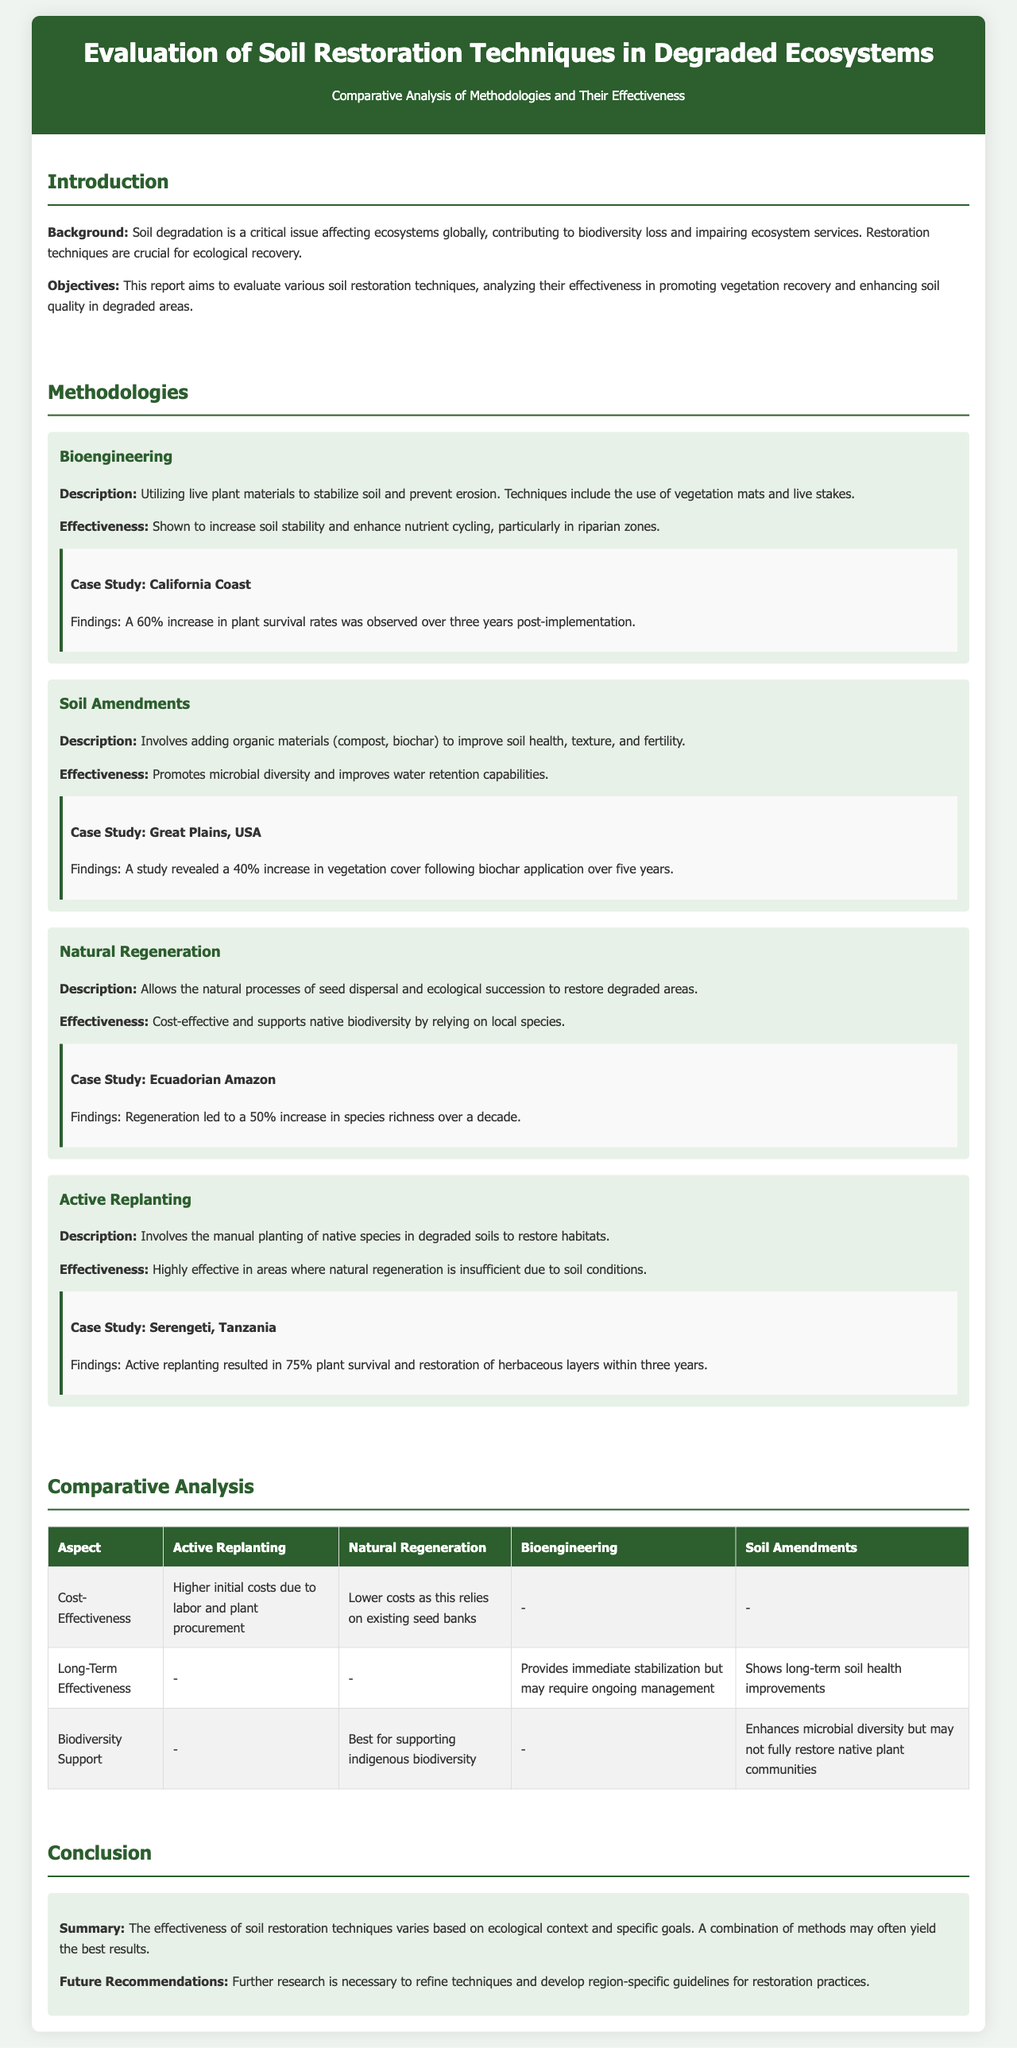What is the primary objective of the report? The report aims to evaluate various soil restoration techniques, analyzing their effectiveness in promoting vegetation recovery and enhancing soil quality in degraded areas.
Answer: evaluating various soil restoration techniques What technique resulted in a 60% increase in plant survival rates? In the case study from California Coast, bioengineering technique showed a 60% increase in plant survival rates over three years post-implementation.
Answer: bioengineering Which methodology showed a 40% increase in vegetation cover? The soil amendments method revealed a 40% increase in vegetation cover following biochar application over five years.
Answer: soil amendments What is the main benefit of natural regeneration? The natural regeneration method is cost-effective and supports native biodiversity by relying on local species.
Answer: cost-effective What aspect has higher initial costs due to labor? Active replanting involves higher initial costs due to labor and plant procurement compared to other methods.
Answer: Active Replanting Which technique is best for supporting indigenous biodiversity? The natural regeneration methodology is recognized for best supporting indigenous biodiversity.
Answer: Natural Regeneration What is emphasized in the conclusion for future practices? The conclusion emphasizes that further research is necessary to refine techniques and develop region-specific guidelines for restoration practices.
Answer: further research Which case study resulted in 75% plant survival? The active replanting case study in the Serengeti, Tanzania led to a 75% plant survival rate.
Answer: Serengeti, Tanzania 